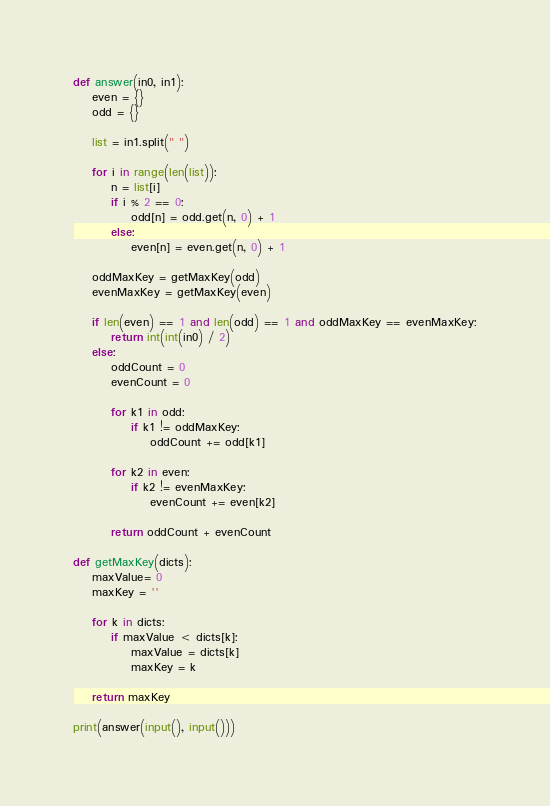Convert code to text. <code><loc_0><loc_0><loc_500><loc_500><_Python_>
def answer(in0, in1):
    even = {}
    odd = {}

    list = in1.split(" ")

    for i in range(len(list)):
        n = list[i]
        if i % 2 == 0:
            odd[n] = odd.get(n, 0) + 1
        else:
            even[n] = even.get(n, 0) + 1

    oddMaxKey = getMaxKey(odd)
    evenMaxKey = getMaxKey(even)

    if len(even) == 1 and len(odd) == 1 and oddMaxKey == evenMaxKey:
        return int(int(in0) / 2)
    else:
        oddCount = 0
        evenCount = 0

        for k1 in odd:
            if k1 != oddMaxKey:
                oddCount += odd[k1]

        for k2 in even:
            if k2 != evenMaxKey:
                evenCount += even[k2]

        return oddCount + evenCount

def getMaxKey(dicts):
    maxValue= 0
    maxKey = ''

    for k in dicts:
        if maxValue < dicts[k]:
            maxValue = dicts[k]
            maxKey = k

    return maxKey

print(answer(input(), input()))
</code> 